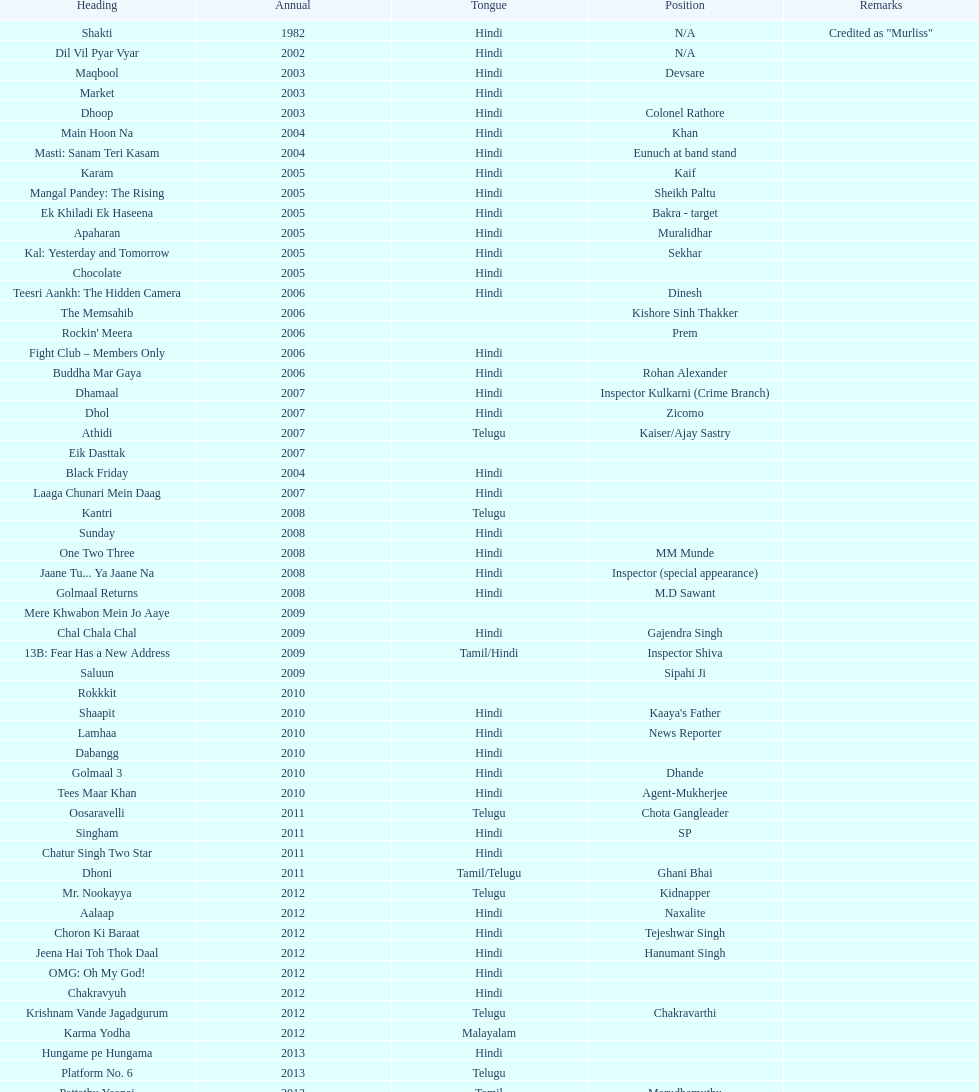In how many different roles has this actor appeared? 36. 